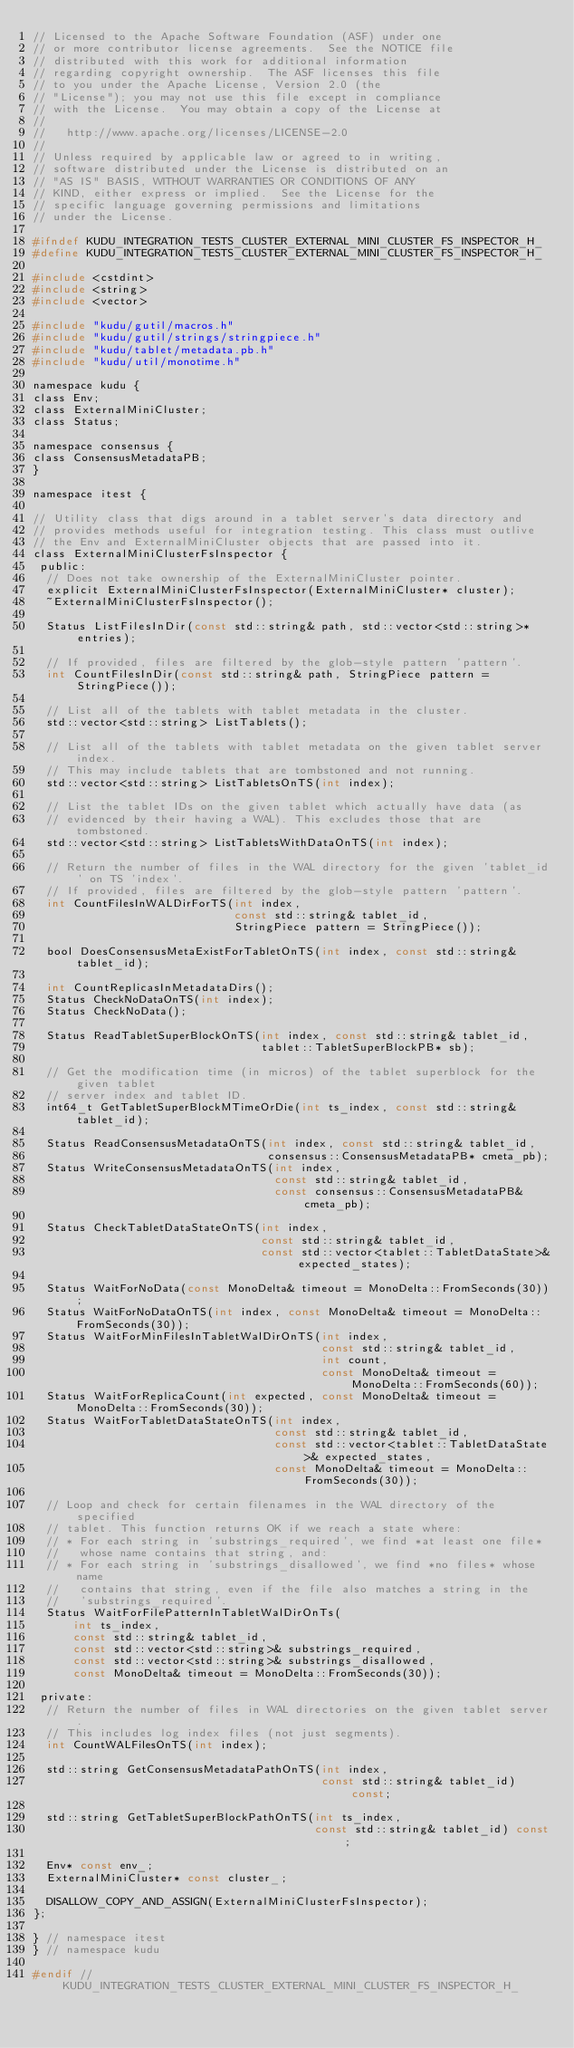<code> <loc_0><loc_0><loc_500><loc_500><_C_>// Licensed to the Apache Software Foundation (ASF) under one
// or more contributor license agreements.  See the NOTICE file
// distributed with this work for additional information
// regarding copyright ownership.  The ASF licenses this file
// to you under the Apache License, Version 2.0 (the
// "License"); you may not use this file except in compliance
// with the License.  You may obtain a copy of the License at
//
//   http://www.apache.org/licenses/LICENSE-2.0
//
// Unless required by applicable law or agreed to in writing,
// software distributed under the License is distributed on an
// "AS IS" BASIS, WITHOUT WARRANTIES OR CONDITIONS OF ANY
// KIND, either express or implied.  See the License for the
// specific language governing permissions and limitations
// under the License.

#ifndef KUDU_INTEGRATION_TESTS_CLUSTER_EXTERNAL_MINI_CLUSTER_FS_INSPECTOR_H_
#define KUDU_INTEGRATION_TESTS_CLUSTER_EXTERNAL_MINI_CLUSTER_FS_INSPECTOR_H_

#include <cstdint>
#include <string>
#include <vector>

#include "kudu/gutil/macros.h"
#include "kudu/gutil/strings/stringpiece.h"
#include "kudu/tablet/metadata.pb.h"
#include "kudu/util/monotime.h"

namespace kudu {
class Env;
class ExternalMiniCluster;
class Status;

namespace consensus {
class ConsensusMetadataPB;
}

namespace itest {

// Utility class that digs around in a tablet server's data directory and
// provides methods useful for integration testing. This class must outlive
// the Env and ExternalMiniCluster objects that are passed into it.
class ExternalMiniClusterFsInspector {
 public:
  // Does not take ownership of the ExternalMiniCluster pointer.
  explicit ExternalMiniClusterFsInspector(ExternalMiniCluster* cluster);
  ~ExternalMiniClusterFsInspector();

  Status ListFilesInDir(const std::string& path, std::vector<std::string>* entries);

  // If provided, files are filtered by the glob-style pattern 'pattern'.
  int CountFilesInDir(const std::string& path, StringPiece pattern = StringPiece());

  // List all of the tablets with tablet metadata in the cluster.
  std::vector<std::string> ListTablets();

  // List all of the tablets with tablet metadata on the given tablet server index.
  // This may include tablets that are tombstoned and not running.
  std::vector<std::string> ListTabletsOnTS(int index);

  // List the tablet IDs on the given tablet which actually have data (as
  // evidenced by their having a WAL). This excludes those that are tombstoned.
  std::vector<std::string> ListTabletsWithDataOnTS(int index);

  // Return the number of files in the WAL directory for the given 'tablet_id' on TS 'index'.
  // If provided, files are filtered by the glob-style pattern 'pattern'.
  int CountFilesInWALDirForTS(int index,
                              const std::string& tablet_id,
                              StringPiece pattern = StringPiece());

  bool DoesConsensusMetaExistForTabletOnTS(int index, const std::string& tablet_id);

  int CountReplicasInMetadataDirs();
  Status CheckNoDataOnTS(int index);
  Status CheckNoData();

  Status ReadTabletSuperBlockOnTS(int index, const std::string& tablet_id,
                                  tablet::TabletSuperBlockPB* sb);

  // Get the modification time (in micros) of the tablet superblock for the given tablet
  // server index and tablet ID.
  int64_t GetTabletSuperBlockMTimeOrDie(int ts_index, const std::string& tablet_id);

  Status ReadConsensusMetadataOnTS(int index, const std::string& tablet_id,
                                   consensus::ConsensusMetadataPB* cmeta_pb);
  Status WriteConsensusMetadataOnTS(int index,
                                    const std::string& tablet_id,
                                    const consensus::ConsensusMetadataPB& cmeta_pb);

  Status CheckTabletDataStateOnTS(int index,
                                  const std::string& tablet_id,
                                  const std::vector<tablet::TabletDataState>& expected_states);

  Status WaitForNoData(const MonoDelta& timeout = MonoDelta::FromSeconds(30));
  Status WaitForNoDataOnTS(int index, const MonoDelta& timeout = MonoDelta::FromSeconds(30));
  Status WaitForMinFilesInTabletWalDirOnTS(int index,
                                           const std::string& tablet_id,
                                           int count,
                                           const MonoDelta& timeout = MonoDelta::FromSeconds(60));
  Status WaitForReplicaCount(int expected, const MonoDelta& timeout = MonoDelta::FromSeconds(30));
  Status WaitForTabletDataStateOnTS(int index,
                                    const std::string& tablet_id,
                                    const std::vector<tablet::TabletDataState>& expected_states,
                                    const MonoDelta& timeout = MonoDelta::FromSeconds(30));

  // Loop and check for certain filenames in the WAL directory of the specified
  // tablet. This function returns OK if we reach a state where:
  // * For each string in 'substrings_required', we find *at least one file*
  //   whose name contains that string, and:
  // * For each string in 'substrings_disallowed', we find *no files* whose name
  //   contains that string, even if the file also matches a string in the
  //   'substrings_required'.
  Status WaitForFilePatternInTabletWalDirOnTs(
      int ts_index,
      const std::string& tablet_id,
      const std::vector<std::string>& substrings_required,
      const std::vector<std::string>& substrings_disallowed,
      const MonoDelta& timeout = MonoDelta::FromSeconds(30));

 private:
  // Return the number of files in WAL directories on the given tablet server.
  // This includes log index files (not just segments).
  int CountWALFilesOnTS(int index);

  std::string GetConsensusMetadataPathOnTS(int index,
                                           const std::string& tablet_id) const;

  std::string GetTabletSuperBlockPathOnTS(int ts_index,
                                          const std::string& tablet_id) const;

  Env* const env_;
  ExternalMiniCluster* const cluster_;

  DISALLOW_COPY_AND_ASSIGN(ExternalMiniClusterFsInspector);
};

} // namespace itest
} // namespace kudu

#endif // KUDU_INTEGRATION_TESTS_CLUSTER_EXTERNAL_MINI_CLUSTER_FS_INSPECTOR_H_
</code> 